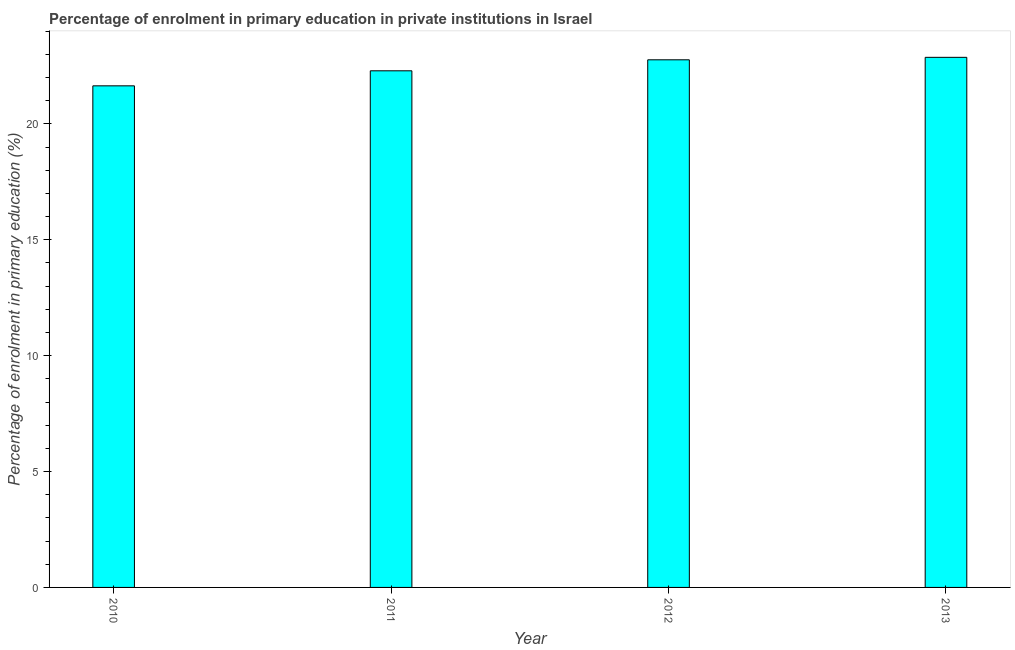Does the graph contain grids?
Your response must be concise. No. What is the title of the graph?
Ensure brevity in your answer.  Percentage of enrolment in primary education in private institutions in Israel. What is the label or title of the X-axis?
Your response must be concise. Year. What is the label or title of the Y-axis?
Your answer should be very brief. Percentage of enrolment in primary education (%). What is the enrolment percentage in primary education in 2011?
Provide a succinct answer. 22.29. Across all years, what is the maximum enrolment percentage in primary education?
Keep it short and to the point. 22.87. Across all years, what is the minimum enrolment percentage in primary education?
Ensure brevity in your answer.  21.64. In which year was the enrolment percentage in primary education maximum?
Your answer should be compact. 2013. In which year was the enrolment percentage in primary education minimum?
Ensure brevity in your answer.  2010. What is the sum of the enrolment percentage in primary education?
Offer a very short reply. 89.58. What is the difference between the enrolment percentage in primary education in 2011 and 2013?
Your answer should be compact. -0.58. What is the average enrolment percentage in primary education per year?
Your answer should be very brief. 22.39. What is the median enrolment percentage in primary education?
Provide a succinct answer. 22.53. In how many years, is the enrolment percentage in primary education greater than 5 %?
Provide a succinct answer. 4. What is the ratio of the enrolment percentage in primary education in 2012 to that in 2013?
Give a very brief answer. 0.99. Is the enrolment percentage in primary education in 2010 less than that in 2011?
Your answer should be very brief. Yes. What is the difference between the highest and the second highest enrolment percentage in primary education?
Your response must be concise. 0.11. What is the difference between the highest and the lowest enrolment percentage in primary education?
Ensure brevity in your answer.  1.23. How many bars are there?
Provide a succinct answer. 4. Are all the bars in the graph horizontal?
Provide a short and direct response. No. How many years are there in the graph?
Your answer should be very brief. 4. What is the difference between two consecutive major ticks on the Y-axis?
Your answer should be very brief. 5. Are the values on the major ticks of Y-axis written in scientific E-notation?
Keep it short and to the point. No. What is the Percentage of enrolment in primary education (%) of 2010?
Your response must be concise. 21.64. What is the Percentage of enrolment in primary education (%) of 2011?
Your response must be concise. 22.29. What is the Percentage of enrolment in primary education (%) in 2012?
Give a very brief answer. 22.77. What is the Percentage of enrolment in primary education (%) in 2013?
Your answer should be compact. 22.87. What is the difference between the Percentage of enrolment in primary education (%) in 2010 and 2011?
Offer a very short reply. -0.65. What is the difference between the Percentage of enrolment in primary education (%) in 2010 and 2012?
Keep it short and to the point. -1.12. What is the difference between the Percentage of enrolment in primary education (%) in 2010 and 2013?
Offer a very short reply. -1.23. What is the difference between the Percentage of enrolment in primary education (%) in 2011 and 2012?
Give a very brief answer. -0.47. What is the difference between the Percentage of enrolment in primary education (%) in 2011 and 2013?
Keep it short and to the point. -0.58. What is the difference between the Percentage of enrolment in primary education (%) in 2012 and 2013?
Give a very brief answer. -0.11. What is the ratio of the Percentage of enrolment in primary education (%) in 2010 to that in 2011?
Offer a very short reply. 0.97. What is the ratio of the Percentage of enrolment in primary education (%) in 2010 to that in 2012?
Provide a succinct answer. 0.95. What is the ratio of the Percentage of enrolment in primary education (%) in 2010 to that in 2013?
Make the answer very short. 0.95. What is the ratio of the Percentage of enrolment in primary education (%) in 2011 to that in 2012?
Ensure brevity in your answer.  0.98. What is the ratio of the Percentage of enrolment in primary education (%) in 2011 to that in 2013?
Offer a terse response. 0.97. What is the ratio of the Percentage of enrolment in primary education (%) in 2012 to that in 2013?
Your answer should be very brief. 0.99. 